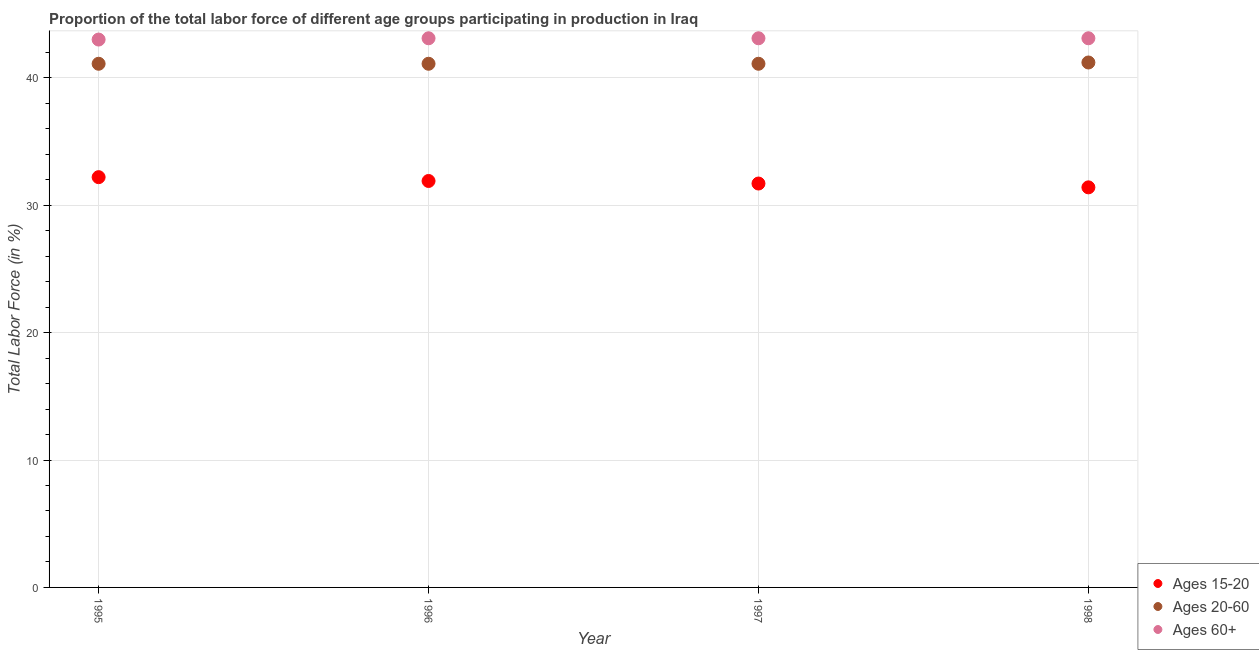What is the percentage of labor force within the age group 15-20 in 1998?
Offer a very short reply. 31.4. Across all years, what is the maximum percentage of labor force within the age group 15-20?
Provide a succinct answer. 32.2. Across all years, what is the minimum percentage of labor force within the age group 20-60?
Provide a short and direct response. 41.1. In which year was the percentage of labor force within the age group 15-20 minimum?
Offer a very short reply. 1998. What is the total percentage of labor force within the age group 15-20 in the graph?
Provide a succinct answer. 127.2. What is the difference between the percentage of labor force within the age group 20-60 in 1995 and that in 1998?
Keep it short and to the point. -0.1. What is the difference between the percentage of labor force within the age group 15-20 in 1998 and the percentage of labor force above age 60 in 1996?
Provide a short and direct response. -11.7. What is the average percentage of labor force within the age group 15-20 per year?
Offer a very short reply. 31.8. In the year 1995, what is the difference between the percentage of labor force within the age group 15-20 and percentage of labor force above age 60?
Your answer should be compact. -10.8. What is the ratio of the percentage of labor force within the age group 20-60 in 1995 to that in 1997?
Give a very brief answer. 1. Is the difference between the percentage of labor force within the age group 15-20 in 1995 and 1997 greater than the difference between the percentage of labor force above age 60 in 1995 and 1997?
Give a very brief answer. Yes. What is the difference between the highest and the second highest percentage of labor force within the age group 15-20?
Your answer should be compact. 0.3. What is the difference between the highest and the lowest percentage of labor force within the age group 15-20?
Offer a terse response. 0.8. Is the sum of the percentage of labor force above age 60 in 1996 and 1998 greater than the maximum percentage of labor force within the age group 15-20 across all years?
Your answer should be compact. Yes. Is it the case that in every year, the sum of the percentage of labor force within the age group 15-20 and percentage of labor force within the age group 20-60 is greater than the percentage of labor force above age 60?
Ensure brevity in your answer.  Yes. Does the percentage of labor force within the age group 20-60 monotonically increase over the years?
Provide a short and direct response. No. Is the percentage of labor force within the age group 20-60 strictly less than the percentage of labor force within the age group 15-20 over the years?
Provide a short and direct response. No. Are the values on the major ticks of Y-axis written in scientific E-notation?
Your response must be concise. No. How are the legend labels stacked?
Ensure brevity in your answer.  Vertical. What is the title of the graph?
Ensure brevity in your answer.  Proportion of the total labor force of different age groups participating in production in Iraq. Does "Tertiary education" appear as one of the legend labels in the graph?
Make the answer very short. No. What is the label or title of the Y-axis?
Keep it short and to the point. Total Labor Force (in %). What is the Total Labor Force (in %) in Ages 15-20 in 1995?
Your answer should be very brief. 32.2. What is the Total Labor Force (in %) in Ages 20-60 in 1995?
Keep it short and to the point. 41.1. What is the Total Labor Force (in %) in Ages 15-20 in 1996?
Keep it short and to the point. 31.9. What is the Total Labor Force (in %) in Ages 20-60 in 1996?
Give a very brief answer. 41.1. What is the Total Labor Force (in %) in Ages 60+ in 1996?
Keep it short and to the point. 43.1. What is the Total Labor Force (in %) in Ages 15-20 in 1997?
Offer a terse response. 31.7. What is the Total Labor Force (in %) of Ages 20-60 in 1997?
Keep it short and to the point. 41.1. What is the Total Labor Force (in %) in Ages 60+ in 1997?
Provide a short and direct response. 43.1. What is the Total Labor Force (in %) in Ages 15-20 in 1998?
Offer a very short reply. 31.4. What is the Total Labor Force (in %) in Ages 20-60 in 1998?
Make the answer very short. 41.2. What is the Total Labor Force (in %) in Ages 60+ in 1998?
Keep it short and to the point. 43.1. Across all years, what is the maximum Total Labor Force (in %) in Ages 15-20?
Your answer should be very brief. 32.2. Across all years, what is the maximum Total Labor Force (in %) in Ages 20-60?
Your response must be concise. 41.2. Across all years, what is the maximum Total Labor Force (in %) of Ages 60+?
Your answer should be compact. 43.1. Across all years, what is the minimum Total Labor Force (in %) in Ages 15-20?
Offer a terse response. 31.4. Across all years, what is the minimum Total Labor Force (in %) of Ages 20-60?
Your response must be concise. 41.1. Across all years, what is the minimum Total Labor Force (in %) in Ages 60+?
Make the answer very short. 43. What is the total Total Labor Force (in %) in Ages 15-20 in the graph?
Provide a succinct answer. 127.2. What is the total Total Labor Force (in %) in Ages 20-60 in the graph?
Provide a succinct answer. 164.5. What is the total Total Labor Force (in %) in Ages 60+ in the graph?
Keep it short and to the point. 172.3. What is the difference between the Total Labor Force (in %) of Ages 15-20 in 1995 and that in 1996?
Make the answer very short. 0.3. What is the difference between the Total Labor Force (in %) in Ages 15-20 in 1995 and that in 1997?
Provide a short and direct response. 0.5. What is the difference between the Total Labor Force (in %) of Ages 20-60 in 1995 and that in 1997?
Your answer should be compact. 0. What is the difference between the Total Labor Force (in %) in Ages 15-20 in 1995 and that in 1998?
Provide a succinct answer. 0.8. What is the difference between the Total Labor Force (in %) of Ages 60+ in 1995 and that in 1998?
Your answer should be very brief. -0.1. What is the difference between the Total Labor Force (in %) in Ages 60+ in 1996 and that in 1998?
Your answer should be compact. 0. What is the difference between the Total Labor Force (in %) in Ages 20-60 in 1997 and that in 1998?
Ensure brevity in your answer.  -0.1. What is the difference between the Total Labor Force (in %) in Ages 15-20 in 1995 and the Total Labor Force (in %) in Ages 20-60 in 1996?
Your answer should be compact. -8.9. What is the difference between the Total Labor Force (in %) in Ages 20-60 in 1995 and the Total Labor Force (in %) in Ages 60+ in 1996?
Ensure brevity in your answer.  -2. What is the difference between the Total Labor Force (in %) in Ages 15-20 in 1995 and the Total Labor Force (in %) in Ages 20-60 in 1997?
Provide a succinct answer. -8.9. What is the difference between the Total Labor Force (in %) in Ages 20-60 in 1995 and the Total Labor Force (in %) in Ages 60+ in 1997?
Offer a very short reply. -2. What is the difference between the Total Labor Force (in %) of Ages 15-20 in 1995 and the Total Labor Force (in %) of Ages 20-60 in 1998?
Give a very brief answer. -9. What is the difference between the Total Labor Force (in %) in Ages 20-60 in 1996 and the Total Labor Force (in %) in Ages 60+ in 1998?
Provide a succinct answer. -2. What is the difference between the Total Labor Force (in %) of Ages 15-20 in 1997 and the Total Labor Force (in %) of Ages 20-60 in 1998?
Give a very brief answer. -9.5. What is the difference between the Total Labor Force (in %) in Ages 15-20 in 1997 and the Total Labor Force (in %) in Ages 60+ in 1998?
Give a very brief answer. -11.4. What is the difference between the Total Labor Force (in %) in Ages 20-60 in 1997 and the Total Labor Force (in %) in Ages 60+ in 1998?
Provide a succinct answer. -2. What is the average Total Labor Force (in %) of Ages 15-20 per year?
Make the answer very short. 31.8. What is the average Total Labor Force (in %) in Ages 20-60 per year?
Your answer should be very brief. 41.12. What is the average Total Labor Force (in %) in Ages 60+ per year?
Your answer should be very brief. 43.08. In the year 1995, what is the difference between the Total Labor Force (in %) in Ages 15-20 and Total Labor Force (in %) in Ages 20-60?
Offer a terse response. -8.9. In the year 1995, what is the difference between the Total Labor Force (in %) in Ages 15-20 and Total Labor Force (in %) in Ages 60+?
Keep it short and to the point. -10.8. In the year 1995, what is the difference between the Total Labor Force (in %) in Ages 20-60 and Total Labor Force (in %) in Ages 60+?
Offer a very short reply. -1.9. In the year 1996, what is the difference between the Total Labor Force (in %) in Ages 15-20 and Total Labor Force (in %) in Ages 20-60?
Your answer should be compact. -9.2. In the year 1996, what is the difference between the Total Labor Force (in %) of Ages 20-60 and Total Labor Force (in %) of Ages 60+?
Keep it short and to the point. -2. In the year 1998, what is the difference between the Total Labor Force (in %) in Ages 15-20 and Total Labor Force (in %) in Ages 20-60?
Provide a succinct answer. -9.8. In the year 1998, what is the difference between the Total Labor Force (in %) of Ages 15-20 and Total Labor Force (in %) of Ages 60+?
Keep it short and to the point. -11.7. What is the ratio of the Total Labor Force (in %) in Ages 15-20 in 1995 to that in 1996?
Provide a succinct answer. 1.01. What is the ratio of the Total Labor Force (in %) in Ages 15-20 in 1995 to that in 1997?
Provide a short and direct response. 1.02. What is the ratio of the Total Labor Force (in %) in Ages 15-20 in 1995 to that in 1998?
Keep it short and to the point. 1.03. What is the ratio of the Total Labor Force (in %) in Ages 20-60 in 1995 to that in 1998?
Offer a terse response. 1. What is the ratio of the Total Labor Force (in %) in Ages 15-20 in 1996 to that in 1997?
Ensure brevity in your answer.  1.01. What is the ratio of the Total Labor Force (in %) of Ages 20-60 in 1996 to that in 1997?
Your response must be concise. 1. What is the ratio of the Total Labor Force (in %) of Ages 60+ in 1996 to that in 1997?
Your answer should be very brief. 1. What is the ratio of the Total Labor Force (in %) of Ages 15-20 in 1996 to that in 1998?
Provide a succinct answer. 1.02. What is the ratio of the Total Labor Force (in %) of Ages 20-60 in 1996 to that in 1998?
Give a very brief answer. 1. What is the ratio of the Total Labor Force (in %) in Ages 60+ in 1996 to that in 1998?
Make the answer very short. 1. What is the ratio of the Total Labor Force (in %) in Ages 15-20 in 1997 to that in 1998?
Offer a terse response. 1.01. What is the ratio of the Total Labor Force (in %) in Ages 60+ in 1997 to that in 1998?
Give a very brief answer. 1. What is the difference between the highest and the second highest Total Labor Force (in %) of Ages 60+?
Keep it short and to the point. 0. What is the difference between the highest and the lowest Total Labor Force (in %) in Ages 15-20?
Keep it short and to the point. 0.8. 